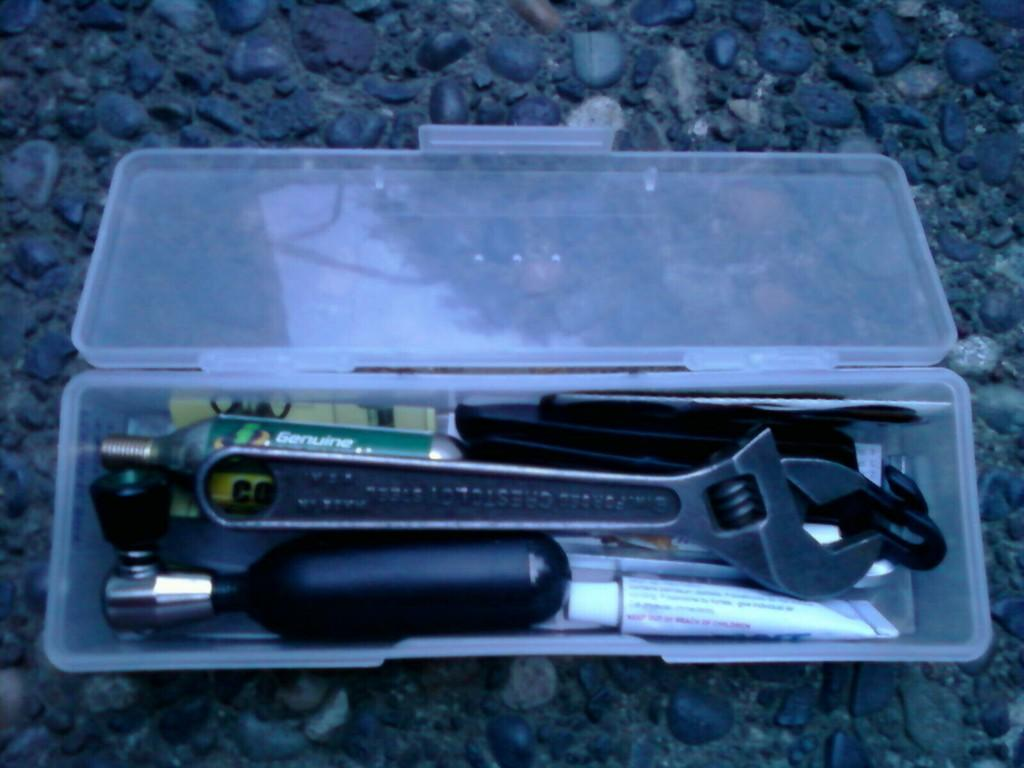What is located on the floor in the image? There is a box of hand tools placed on the floor. Can you describe the contents of the box in the image? The box contains hand tools. How many cows are grazing in the background of the image? There are no cows present in the image; it only features a box of hand tools placed on the floor. 